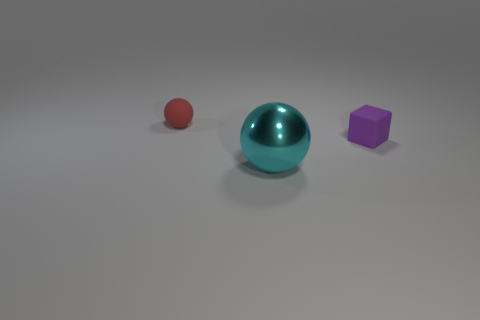What materials do the objects in the image look like they are made from? The objects in the image appear to be made from materials with different textures. The large cyan sphere seems to have a smooth, perhaps metallic or plastic surface, reflecting light and casting a slight shadow. The small red sphere looks similar in texture, implying a glossy material. On the other hand, the purple cube appears to have a matte finish, possibly suggesting a more rubbery or frosted plastic material. 